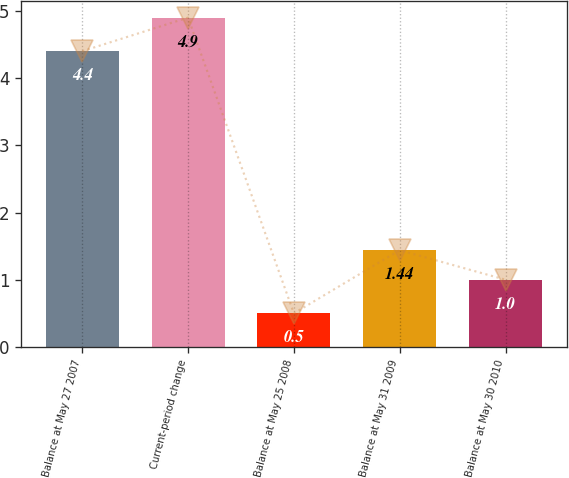Convert chart. <chart><loc_0><loc_0><loc_500><loc_500><bar_chart><fcel>Balance at May 27 2007<fcel>Current-period change<fcel>Balance at May 25 2008<fcel>Balance at May 31 2009<fcel>Balance at May 30 2010<nl><fcel>4.4<fcel>4.9<fcel>0.5<fcel>1.44<fcel>1<nl></chart> 